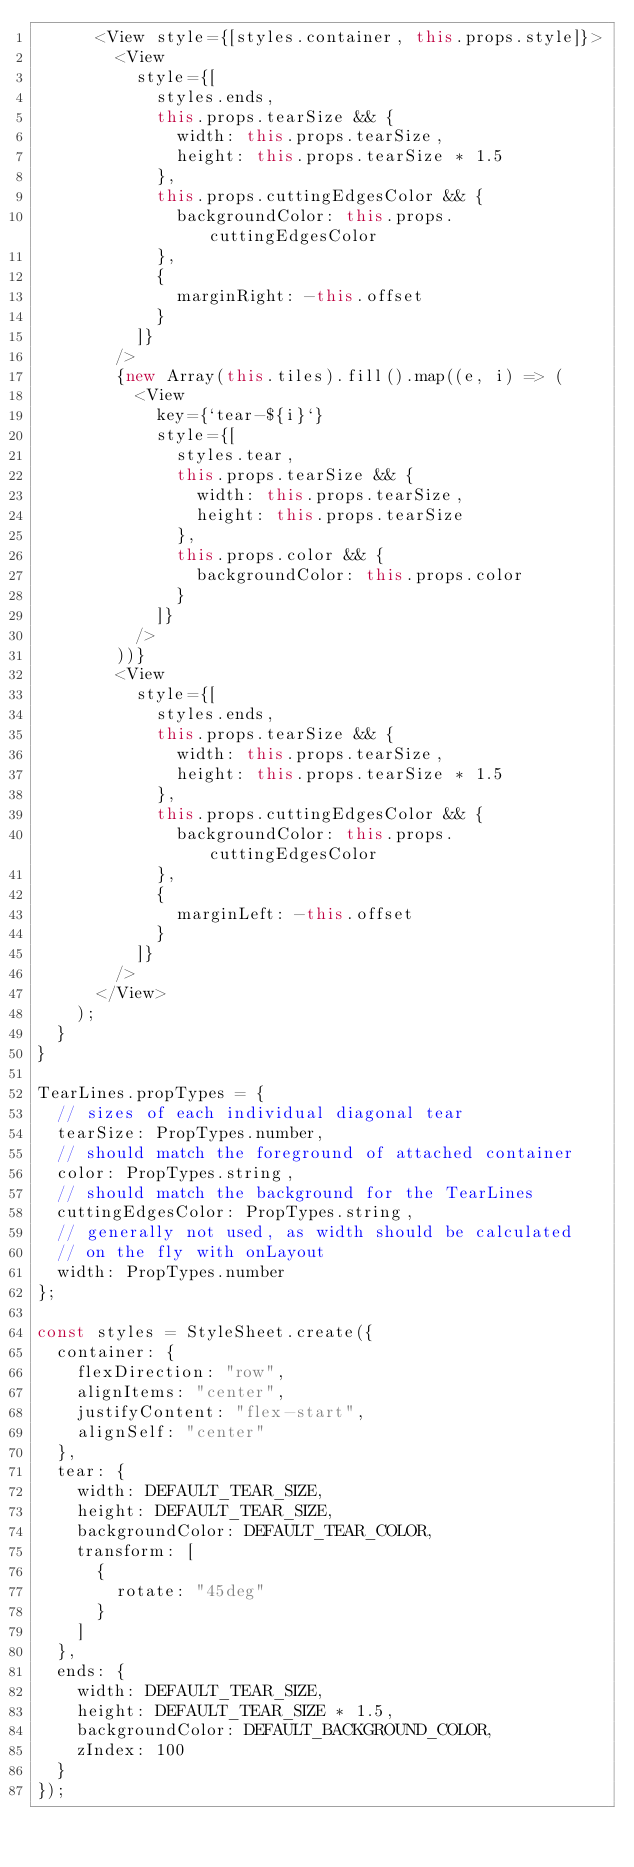<code> <loc_0><loc_0><loc_500><loc_500><_JavaScript_>      <View style={[styles.container, this.props.style]}>
        <View
          style={[
            styles.ends,
            this.props.tearSize && {
              width: this.props.tearSize,
              height: this.props.tearSize * 1.5
            },
            this.props.cuttingEdgesColor && {
              backgroundColor: this.props.cuttingEdgesColor
            },
            {
              marginRight: -this.offset
            }
          ]}
        />
        {new Array(this.tiles).fill().map((e, i) => (
          <View
            key={`tear-${i}`}
            style={[
              styles.tear,
              this.props.tearSize && {
                width: this.props.tearSize,
                height: this.props.tearSize
              },
              this.props.color && {
                backgroundColor: this.props.color
              }
            ]}
          />
        ))}
        <View
          style={[
            styles.ends,
            this.props.tearSize && {
              width: this.props.tearSize,
              height: this.props.tearSize * 1.5
            },
            this.props.cuttingEdgesColor && {
              backgroundColor: this.props.cuttingEdgesColor
            },
            {
              marginLeft: -this.offset
            }
          ]}
        />
      </View>
    );
  }
}

TearLines.propTypes = {
  // sizes of each individual diagonal tear
  tearSize: PropTypes.number,
  // should match the foreground of attached container
  color: PropTypes.string,
  // should match the background for the TearLines
  cuttingEdgesColor: PropTypes.string,
  // generally not used, as width should be calculated
  // on the fly with onLayout
  width: PropTypes.number
};

const styles = StyleSheet.create({
  container: {
    flexDirection: "row",
    alignItems: "center",
    justifyContent: "flex-start",
    alignSelf: "center"
  },
  tear: {
    width: DEFAULT_TEAR_SIZE,
    height: DEFAULT_TEAR_SIZE,
    backgroundColor: DEFAULT_TEAR_COLOR,
    transform: [
      {
        rotate: "45deg"
      }
    ]
  },
  ends: {
    width: DEFAULT_TEAR_SIZE,
    height: DEFAULT_TEAR_SIZE * 1.5,
    backgroundColor: DEFAULT_BACKGROUND_COLOR,
    zIndex: 100
  }
});
</code> 